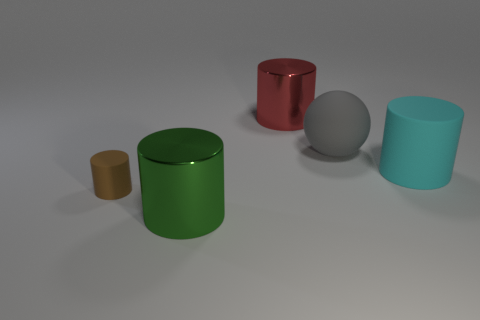Is there anything else that is the same material as the large green cylinder?
Your answer should be compact. Yes. There is a red cylinder that is the same material as the green cylinder; what size is it?
Offer a very short reply. Large. Is there a small brown rubber thing that has the same shape as the gray thing?
Your response must be concise. No. How many objects are things behind the green thing or big balls?
Keep it short and to the point. 4. There is a large cylinder that is behind the large cyan object; does it have the same color as the rubber cylinder that is in front of the cyan cylinder?
Your answer should be compact. No. What size is the green shiny cylinder?
Keep it short and to the point. Large. What number of large things are shiny cylinders or cyan cylinders?
Provide a succinct answer. 3. What color is the other metallic thing that is the same size as the red metal object?
Offer a very short reply. Green. What number of other objects are there of the same shape as the green shiny thing?
Make the answer very short. 3. Is there a gray ball made of the same material as the red cylinder?
Offer a very short reply. No. 